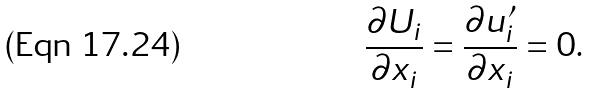<formula> <loc_0><loc_0><loc_500><loc_500>\frac { \partial U _ { i } } { \partial x _ { i } } = \frac { \partial u ^ { \prime } _ { i } } { \partial x _ { i } } = 0 .</formula> 